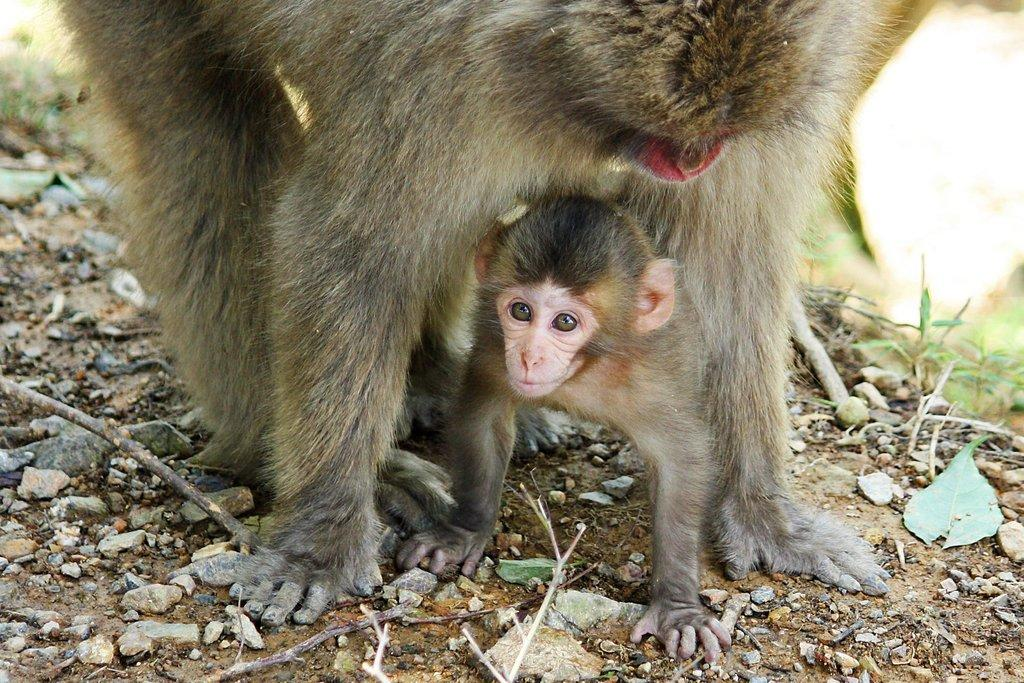How many monkeys are in the image? There are two monkeys in the image. What colors are the monkeys in the image? The monkeys are in grey, cream, and brown colors. What natural elements are present in the image? There are stones, sticks, and grass in the image. What type of yam is being used as a prop in the image? There is no yam present in the image; it features two monkeys and natural elements such as stones, sticks, and grass. 